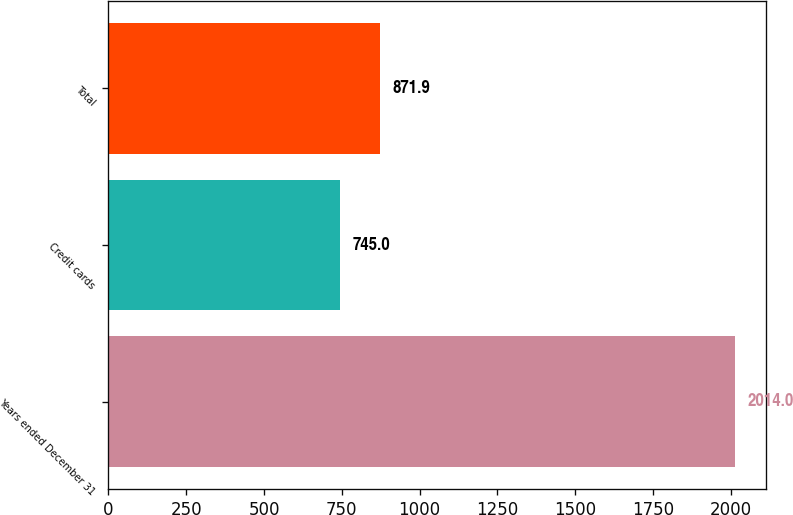Convert chart to OTSL. <chart><loc_0><loc_0><loc_500><loc_500><bar_chart><fcel>Years ended December 31<fcel>Credit cards<fcel>Total<nl><fcel>2014<fcel>745<fcel>871.9<nl></chart> 